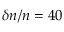<formula> <loc_0><loc_0><loc_500><loc_500>\delta n / n = 4 0 \</formula> 